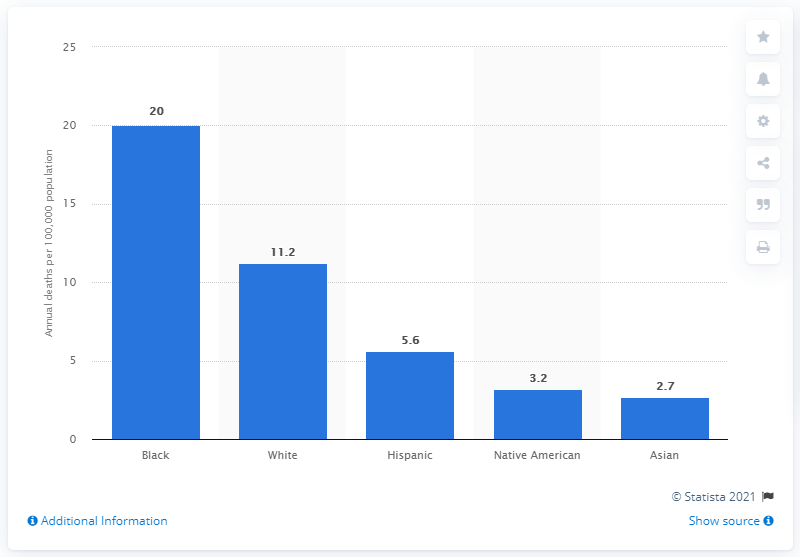List a handful of essential elements in this visual. According to recent statistics, the white population in the United States has an average of 11.2 gun deaths per 100,000 people. 